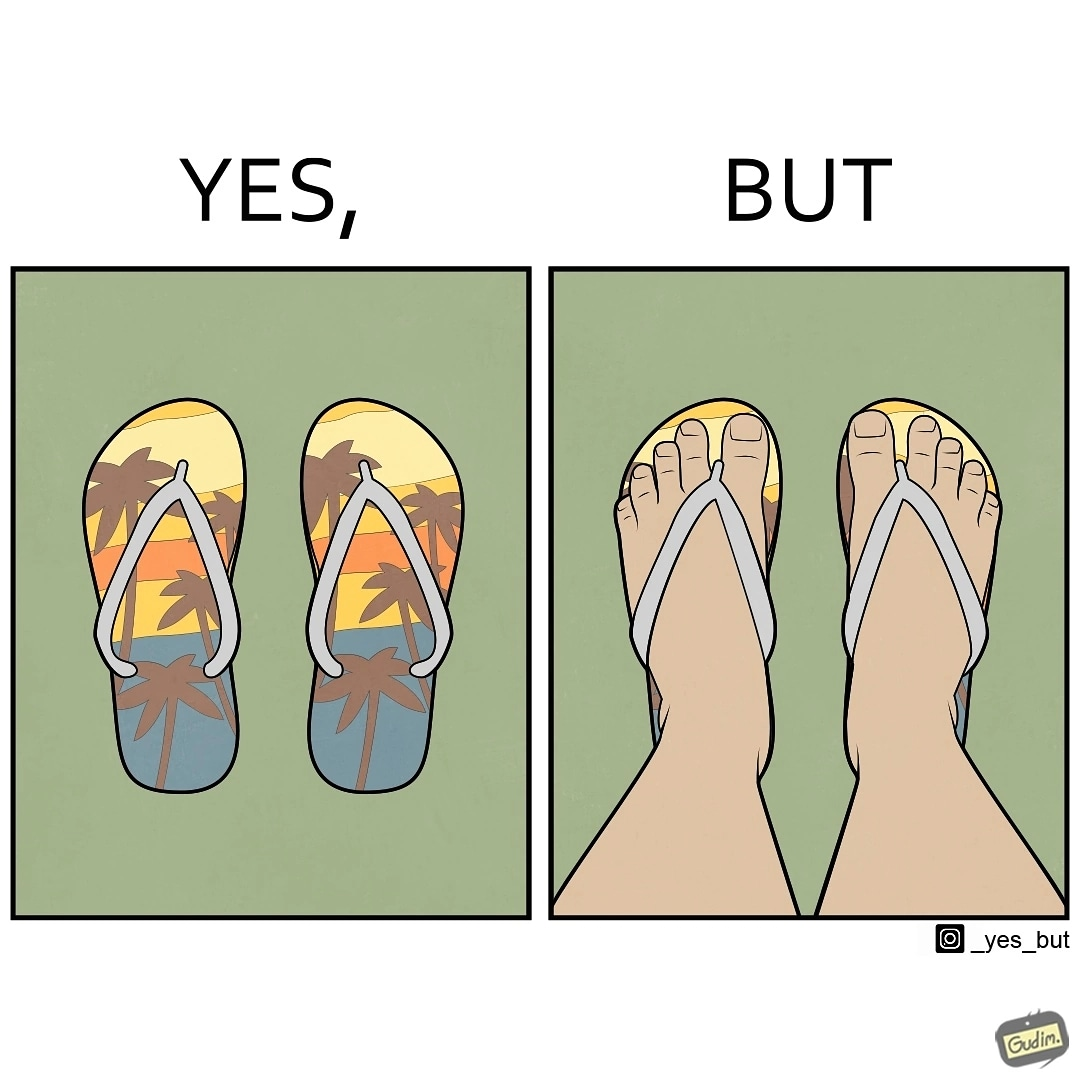Why is this image considered satirical? The image is ironical, as when a person wear a pair of slippers with a colorful image, it is almost completely hidden due to the legs of the person wearing the slippers, which counters the point of having such colorful slippers. 